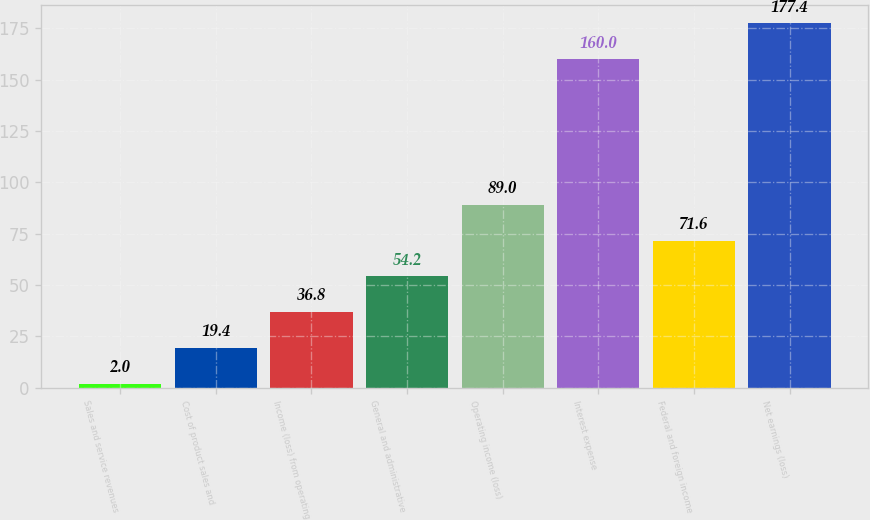Convert chart. <chart><loc_0><loc_0><loc_500><loc_500><bar_chart><fcel>Sales and service revenues<fcel>Cost of product sales and<fcel>Income (loss) from operating<fcel>General and administrative<fcel>Operating income (loss)<fcel>Interest expense<fcel>Federal and foreign income<fcel>Net earnings (loss)<nl><fcel>2<fcel>19.4<fcel>36.8<fcel>54.2<fcel>89<fcel>160<fcel>71.6<fcel>177.4<nl></chart> 